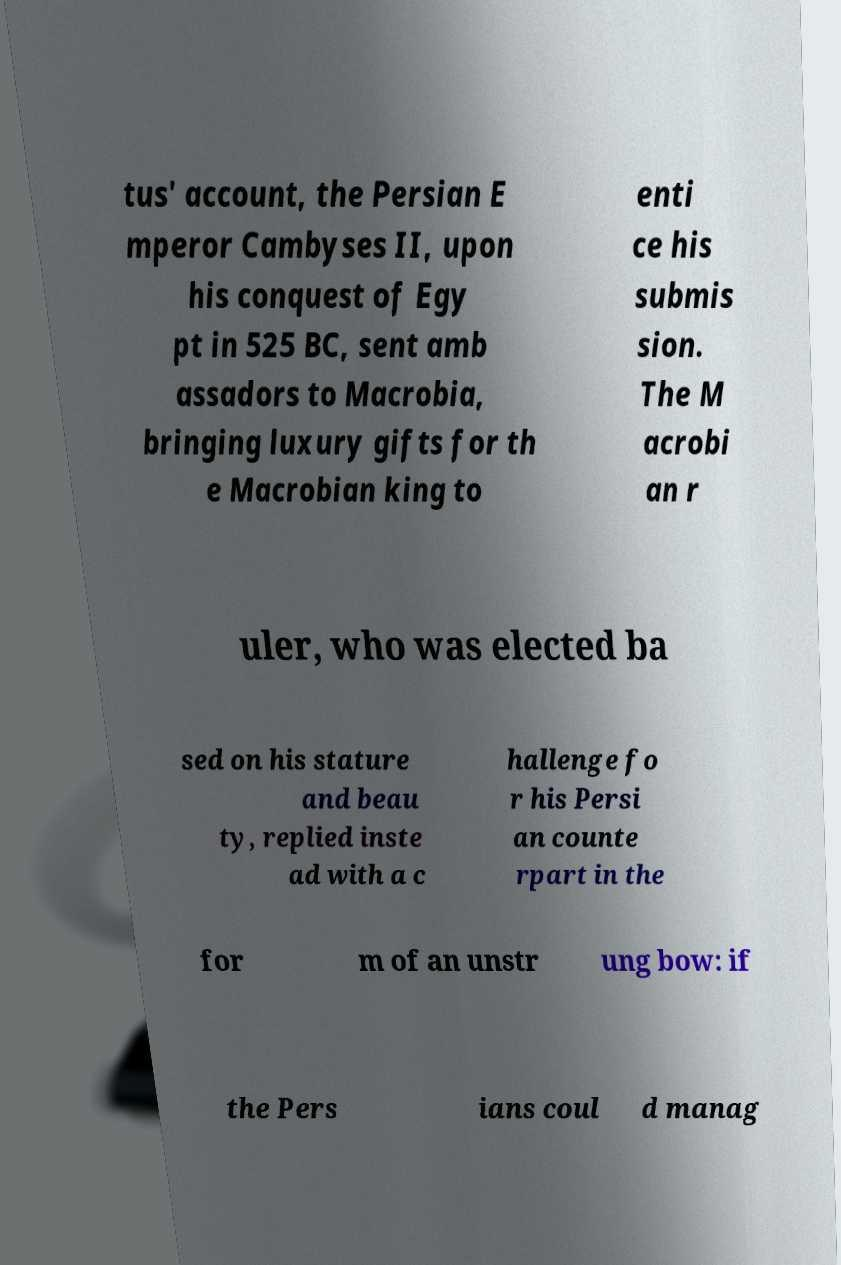Please read and relay the text visible in this image. What does it say? tus' account, the Persian E mperor Cambyses II, upon his conquest of Egy pt in 525 BC, sent amb assadors to Macrobia, bringing luxury gifts for th e Macrobian king to enti ce his submis sion. The M acrobi an r uler, who was elected ba sed on his stature and beau ty, replied inste ad with a c hallenge fo r his Persi an counte rpart in the for m of an unstr ung bow: if the Pers ians coul d manag 